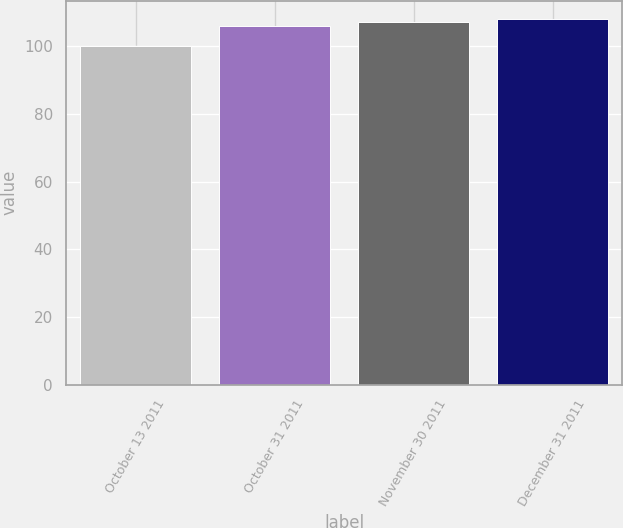Convert chart. <chart><loc_0><loc_0><loc_500><loc_500><bar_chart><fcel>October 13 2011<fcel>October 31 2011<fcel>November 30 2011<fcel>December 31 2011<nl><fcel>100<fcel>106<fcel>107<fcel>108<nl></chart> 